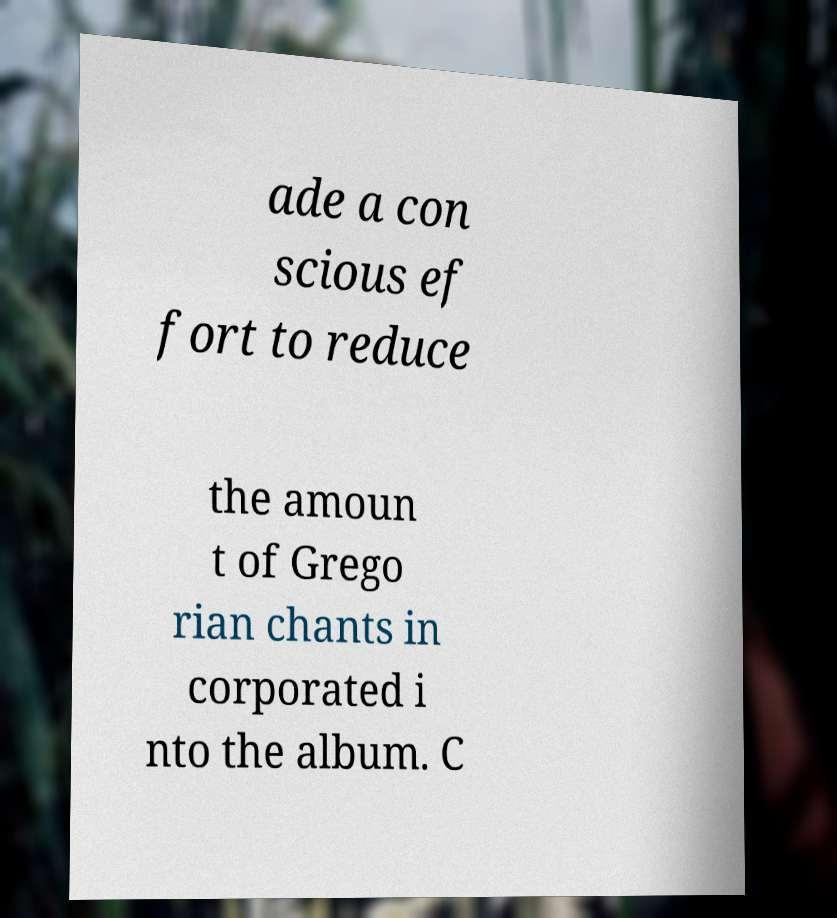For documentation purposes, I need the text within this image transcribed. Could you provide that? ade a con scious ef fort to reduce the amoun t of Grego rian chants in corporated i nto the album. C 